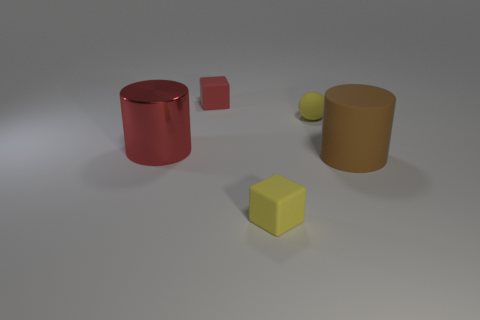Add 3 yellow blocks. How many objects exist? 8 Subtract all cylinders. How many objects are left? 3 Subtract all small cyan things. Subtract all brown rubber things. How many objects are left? 4 Add 4 yellow blocks. How many yellow blocks are left? 5 Add 5 yellow rubber things. How many yellow rubber things exist? 7 Subtract 0 blue balls. How many objects are left? 5 Subtract all red cylinders. Subtract all blue spheres. How many cylinders are left? 1 